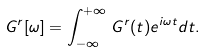Convert formula to latex. <formula><loc_0><loc_0><loc_500><loc_500>G ^ { r } [ \omega ] = \int _ { - \infty } ^ { + \infty } \, G ^ { r } ( t ) e ^ { i \omega t } d t .</formula> 